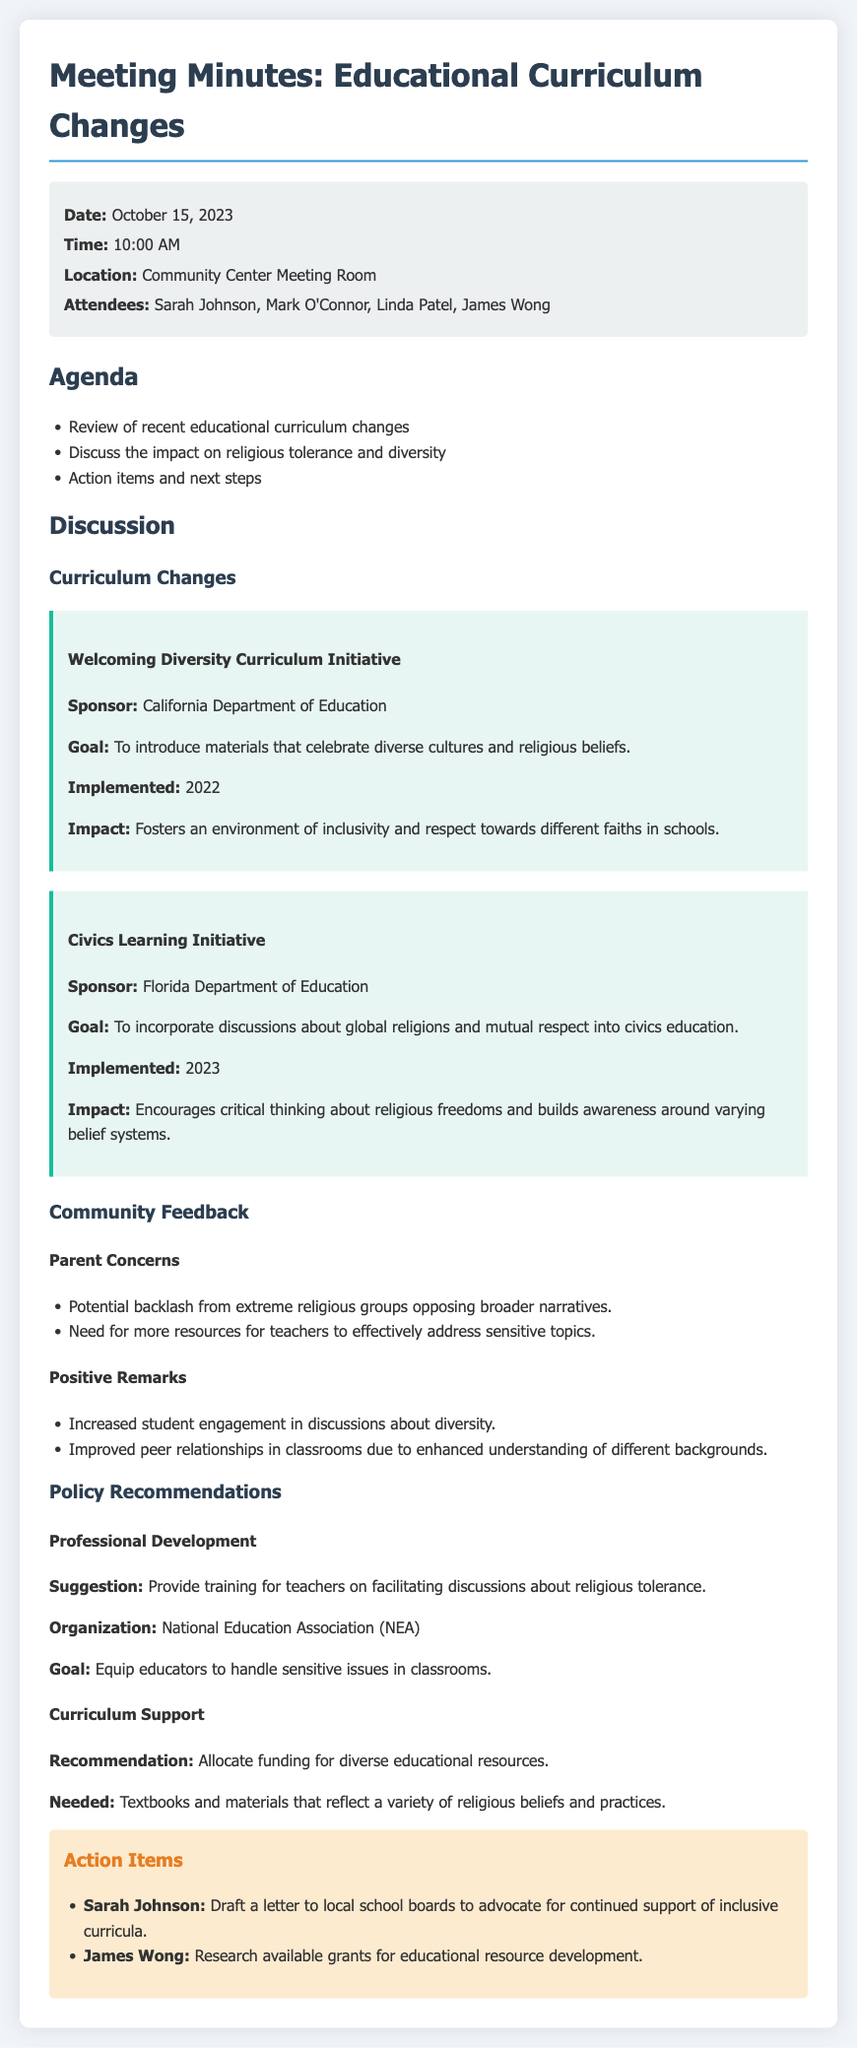What is the date of the meeting? The date of the meeting is given in the meta-info section of the document.
Answer: October 15, 2023 Who are the attendees of the meeting? The attendees are listed under the meta-info section, providing their names directly.
Answer: Sarah Johnson, Mark O'Connor, Linda Patel, James Wong What is the goal of the Welcoming Diversity Curriculum Initiative? The goal is outlined in the discussion about the curriculum changes.
Answer: To introduce materials that celebrate diverse cultures and religious beliefs What are some parent concerns mentioned in the meeting? The parent concerns are outlined in a bullet point list under community feedback.
Answer: Potential backlash from extreme religious groups opposing broader narratives What is one positive remark about the curriculum changes? The positive remarks are listed in a bullet point format under community feedback.
Answer: Increased student engagement in discussions about diversity What organization is suggested for professional development? The organization is specified in the policy recommendations section.
Answer: National Education Association (NEA) What funding is recommended for curriculum support? The recommendation details the type of funding needed in the policy recommendations section.
Answer: Allocate funding for diverse educational resources Who is responsible for drafting a letter to local school boards? The action items section details who is responsible for each task.
Answer: Sarah Johnson 